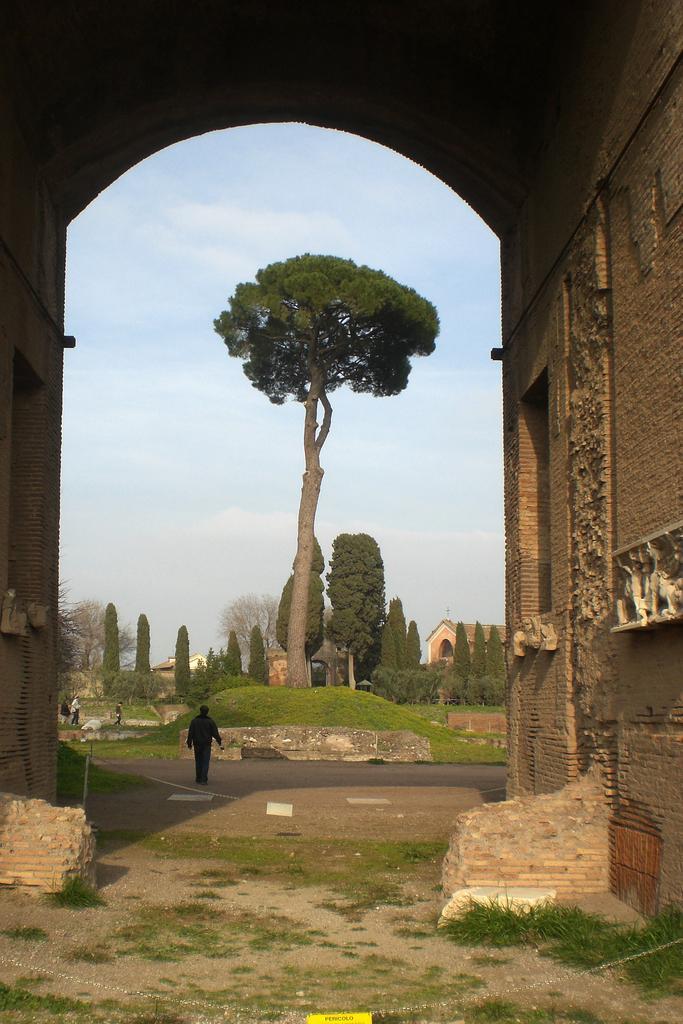Could you give a brief overview of what you see in this image? This picture shows a man walking and we see few trees and buildings and a blue cloudy sky. 